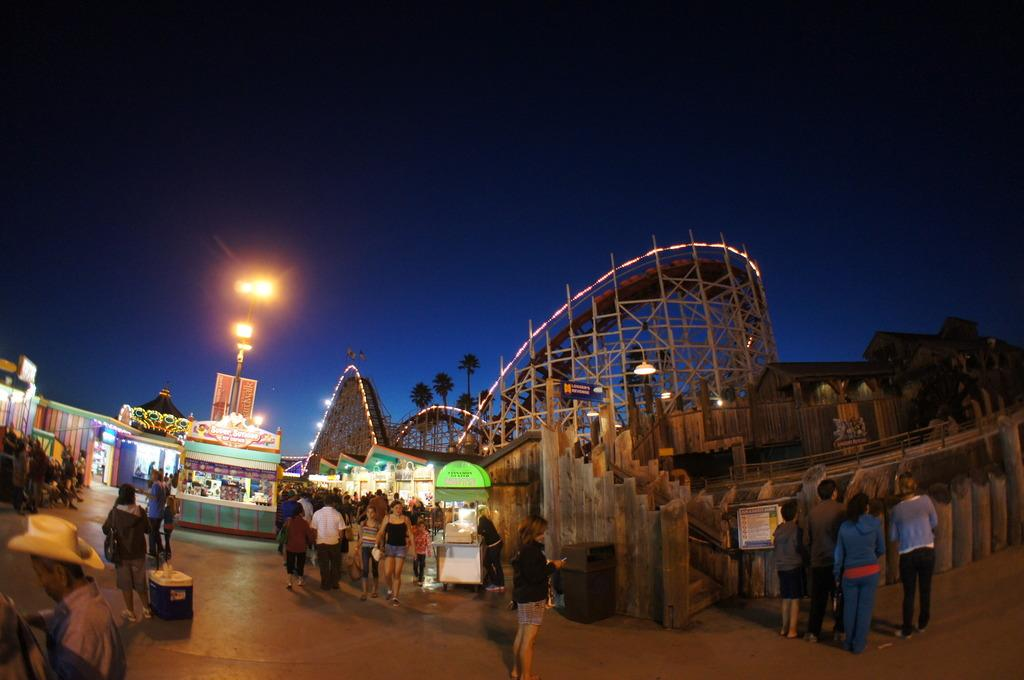How many people can be seen in the image? There are people in the image, but the exact number is not specified. What objects are present on the surface in the image? There is a box and a bin on the surface in the image. What type of structures are visible in the image? There are stalls and houses in the image. What other objects can be seen in the image? There are rods, lights, a fence, a board, and a pole in the image. What can be seen in the background of the image? There are trees and a blue sky in the background of the image. What type of smell can be detected from the basket in the image? There is no basket present in the image, so it is not possible to determine any associated smell. 